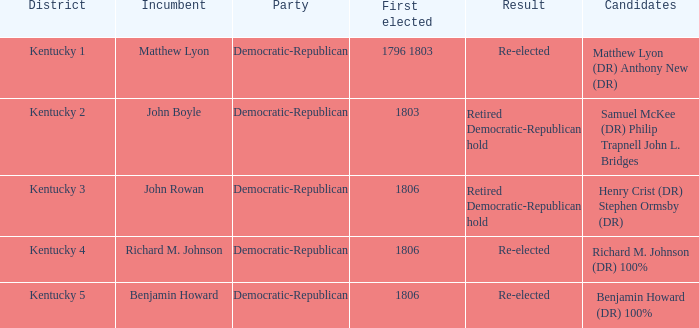Name the incumbent for  matthew lyon (dr) anthony new (dr) Matthew Lyon. 